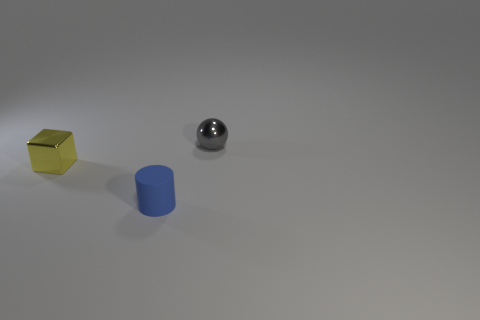Add 1 tiny yellow metallic objects. How many objects exist? 4 Subtract 1 balls. How many balls are left? 0 Subtract all cylinders. How many objects are left? 2 Add 2 tiny gray objects. How many tiny gray objects exist? 3 Subtract 1 blue cylinders. How many objects are left? 2 Subtract all purple cylinders. How many red blocks are left? 0 Subtract all blue rubber things. Subtract all tiny rubber objects. How many objects are left? 1 Add 3 rubber objects. How many rubber objects are left? 4 